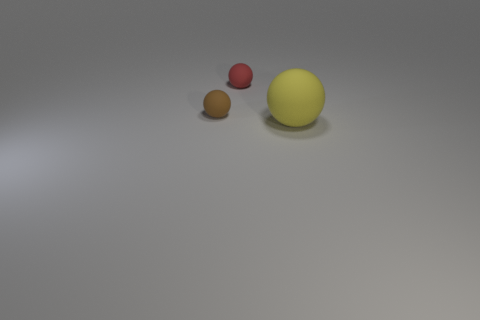How do the colors of the balls contrast with their surroundings? The red and yellow balls provide a vivid contrast to the neutral gray background, while the brown ball blends more subtly into the scene. The contrasting colors draw the viewer's attention and may serve to highlight the objects' geometrical simplicity. 